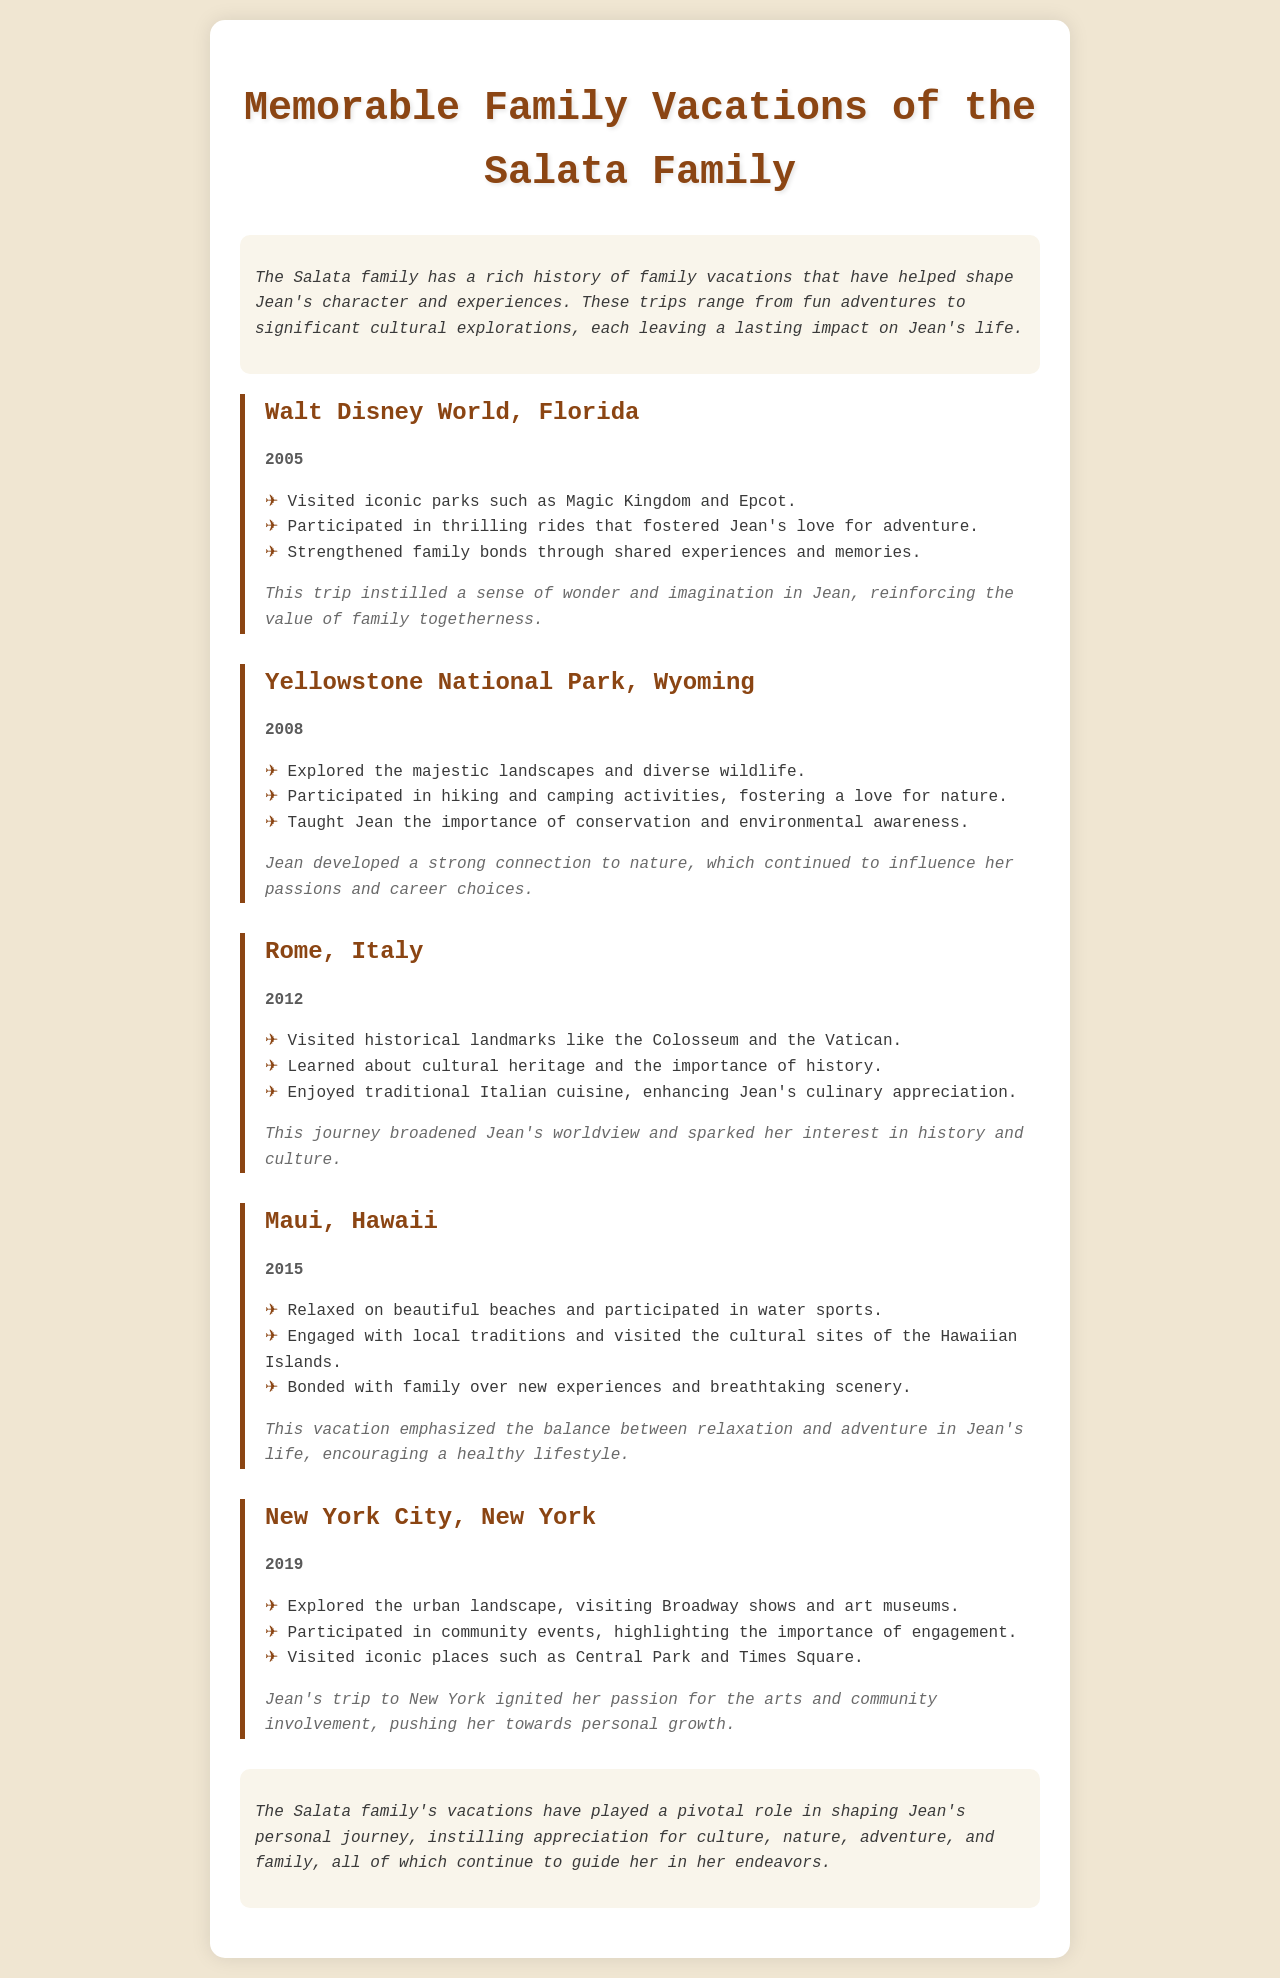What was the first vacation destination? The first vacation mentioned in the document is in 2005, and it highlights Walt Disney World, Florida.
Answer: Walt Disney World, Florida In which year did the Salata family visit Yellowstone National Park? The document specifies the vacation to Yellowstone National Park took place in 2008.
Answer: 2008 What significant value did the Walt Disney World trip reinforce in Jean? The trip instilled a sense of wonder and imagination, emphasizing the importance of family togetherness.
Answer: Family togetherness Which vacation sparked Jean's interest in history and culture? The trip to Rome, Italy in 2012, as indicated in the highlights, broadened Jean's worldview and interest in history.
Answer: Rome, Italy How many vacations are listed in the document? The document lists a total of five memorable family vacations taken by the Salata family.
Answer: Five What activities did Jean engage in during the Maui vacation? The poignant experiences highlighted in the document include relaxing on beaches and participating in water sports during the Maui trip.
Answer: Water sports Which city did Jean visit that emphasized community involvement? New York City is mentioned as the destination that highlighted Jean's participation in community events.
Answer: New York City What overarching theme do the Salata family's vacations share? The vacations collectively emphasize the appreciation for culture, nature, adventure, and family, as explained in the conclusion.
Answer: Culture, nature, adventure, and family 